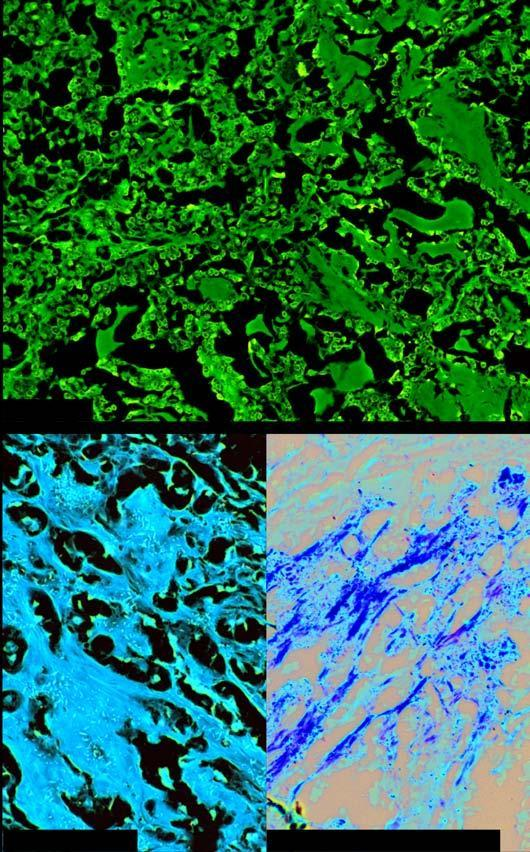does microscopy show organoid pattern of oval tumour cells and abundant amyloid stroma?
Answer the question using a single word or phrase. Yes 